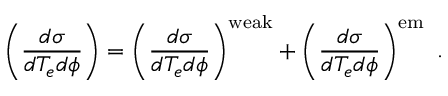<formula> <loc_0><loc_0><loc_500><loc_500>\left ( \frac { d \sigma } { d T _ { e } d \phi } \right ) = \left ( \frac { d \sigma } { d T _ { e } d \phi } \right ) ^ { w e a k } + \left ( \frac { d \sigma } { d T _ { e } d \phi } \right ) ^ { e m } .</formula> 